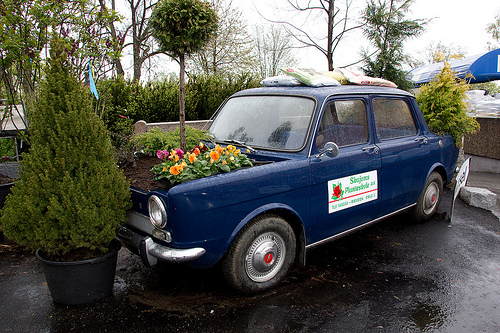<image>
Is there a flower next to the car? No. The flower is not positioned next to the car. They are located in different areas of the scene. Is there a flowers in front of the car? No. The flowers is not in front of the car. The spatial positioning shows a different relationship between these objects. 